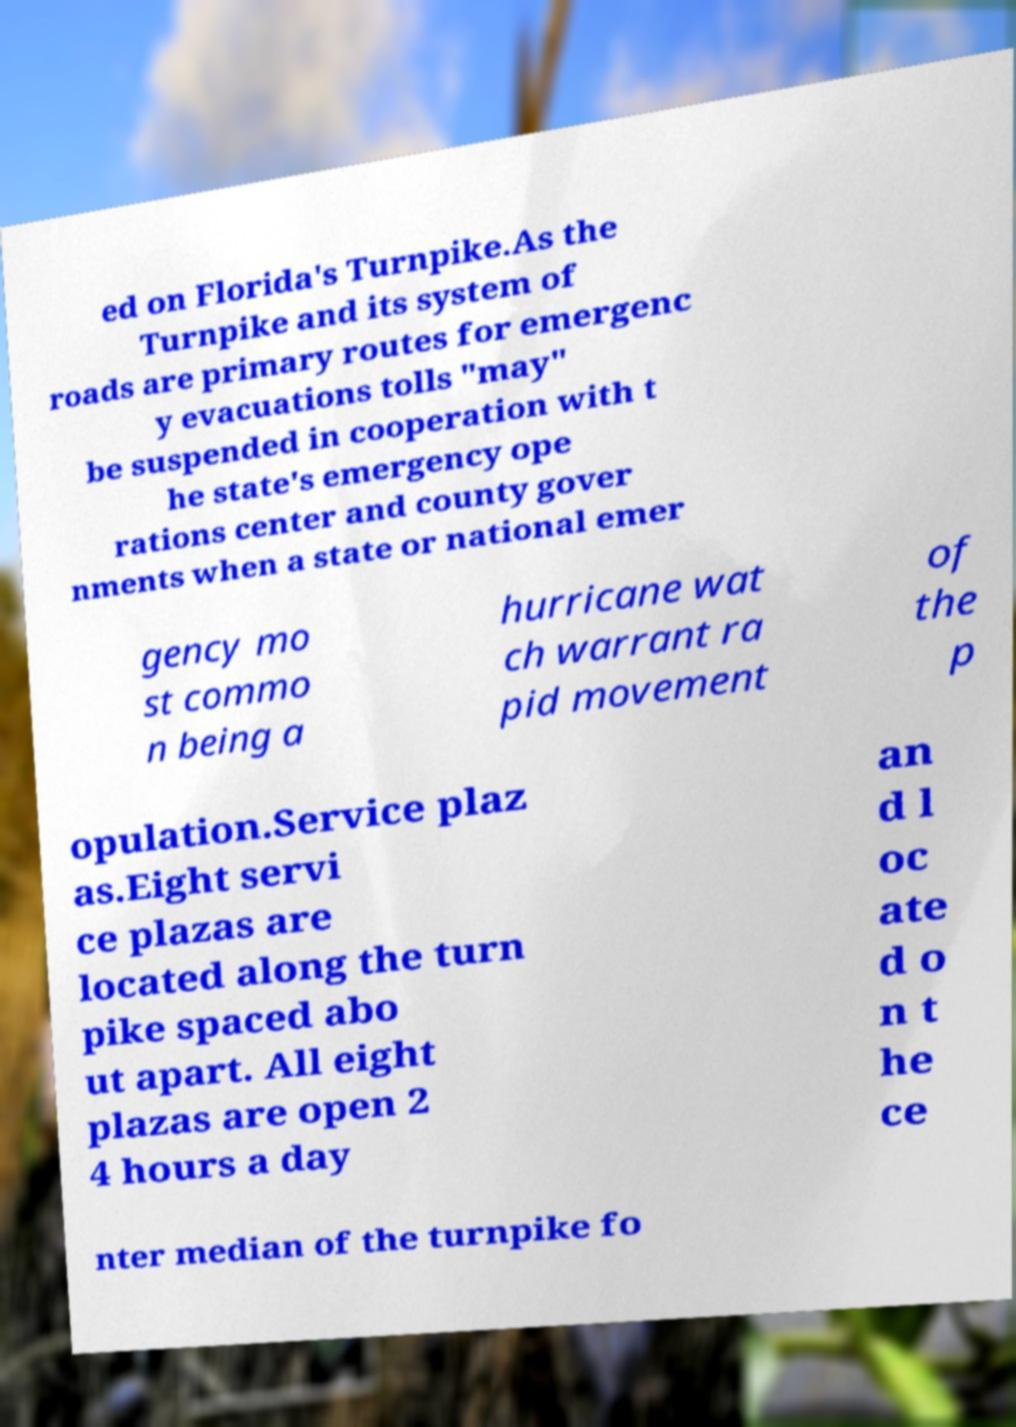Could you extract and type out the text from this image? ed on Florida's Turnpike.As the Turnpike and its system of roads are primary routes for emergenc y evacuations tolls "may" be suspended in cooperation with t he state's emergency ope rations center and county gover nments when a state or national emer gency mo st commo n being a hurricane wat ch warrant ra pid movement of the p opulation.Service plaz as.Eight servi ce plazas are located along the turn pike spaced abo ut apart. All eight plazas are open 2 4 hours a day an d l oc ate d o n t he ce nter median of the turnpike fo 